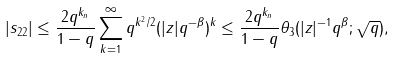<formula> <loc_0><loc_0><loc_500><loc_500>| s _ { 2 2 } | \leq \frac { 2 q ^ { k _ { n } } } { 1 - q } \sum _ { k = 1 } ^ { \infty } q ^ { k ^ { 2 } / 2 } ( | z | q ^ { - \beta } ) ^ { k } \leq \frac { 2 q ^ { k _ { n } } } { 1 - q } \theta _ { 3 } ( | z | ^ { - 1 } q ^ { \beta } ; \sqrt { q } ) ,</formula> 